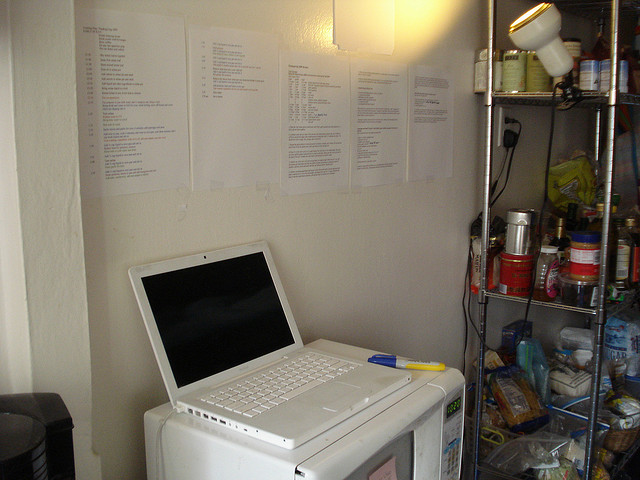Are there any objects placed next to the honey jar? Yes, there are several cans and jars positioned near the honey jar on the shelf. 